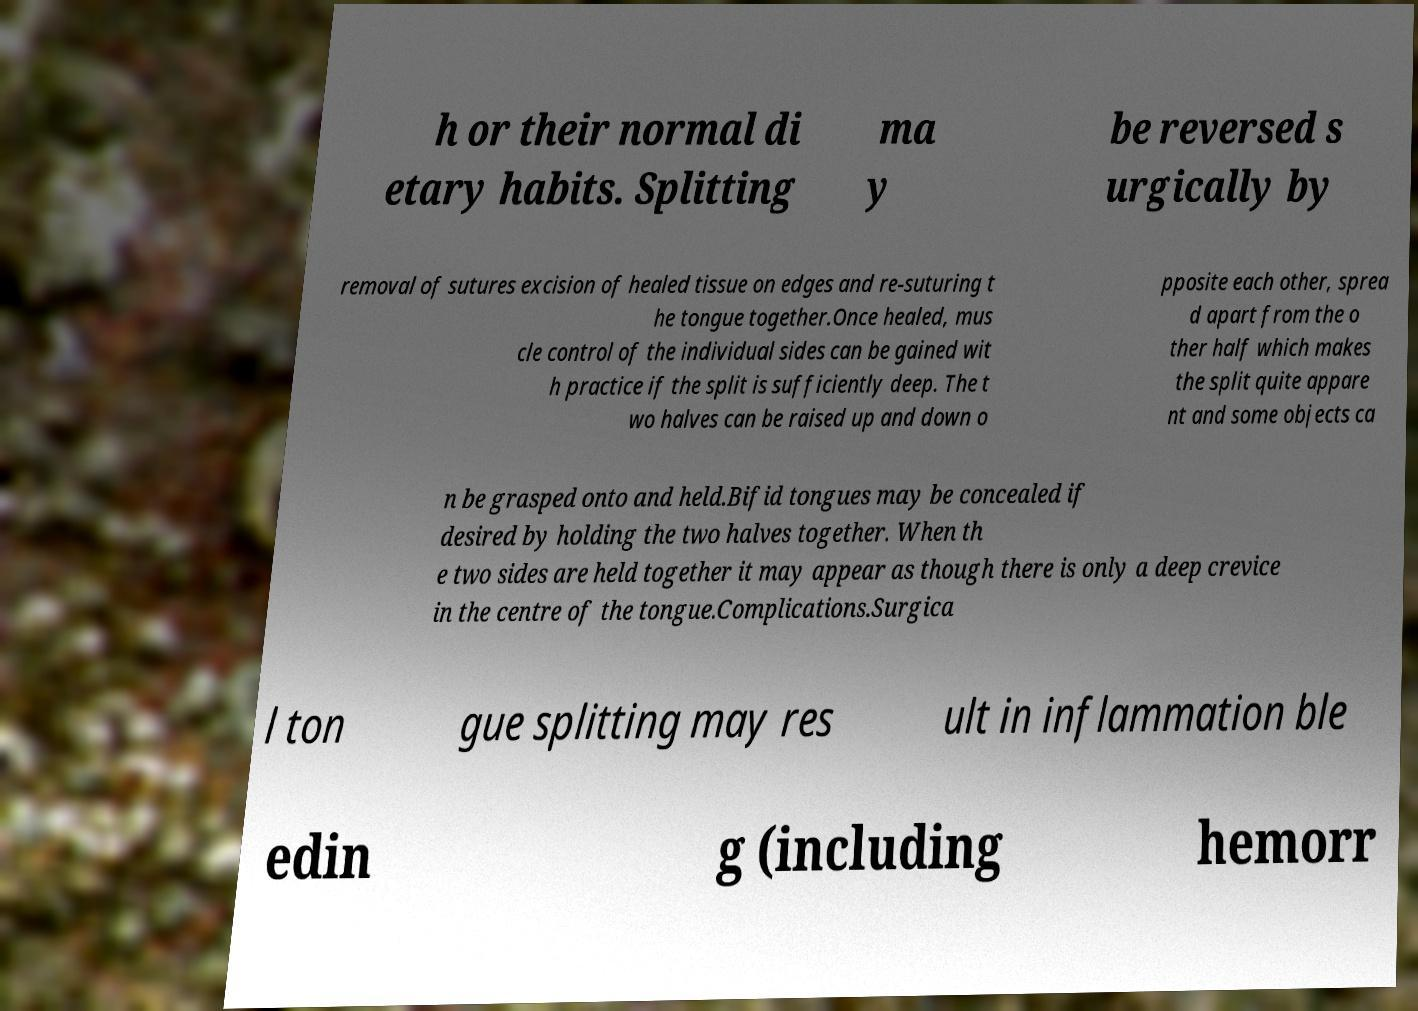Could you assist in decoding the text presented in this image and type it out clearly? h or their normal di etary habits. Splitting ma y be reversed s urgically by removal of sutures excision of healed tissue on edges and re-suturing t he tongue together.Once healed, mus cle control of the individual sides can be gained wit h practice if the split is sufficiently deep. The t wo halves can be raised up and down o pposite each other, sprea d apart from the o ther half which makes the split quite appare nt and some objects ca n be grasped onto and held.Bifid tongues may be concealed if desired by holding the two halves together. When th e two sides are held together it may appear as though there is only a deep crevice in the centre of the tongue.Complications.Surgica l ton gue splitting may res ult in inflammation ble edin g (including hemorr 